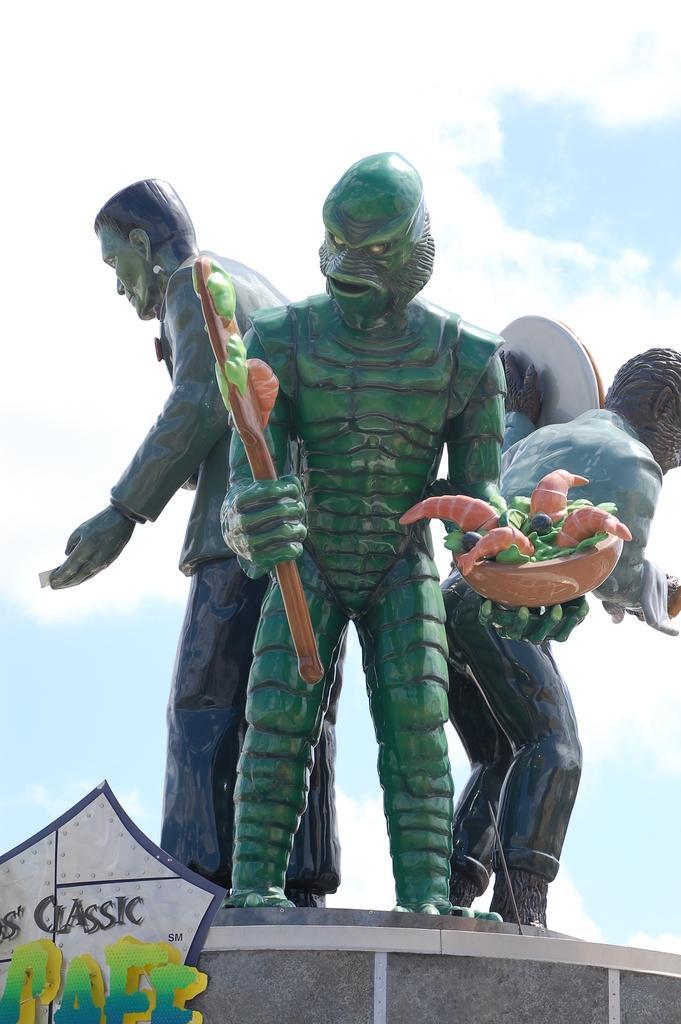In one or two sentences, can you explain what this image depicts? In front of the picture, we see a green color statue, which is holding a stick and a bowl containing vegetables. Beside that, we see two statues. At the bottom, we see a grey color wall. In the left bottom, we see a board in white color with some text written in grey, green and blue color. In the background, we see the clouds and the sky. 